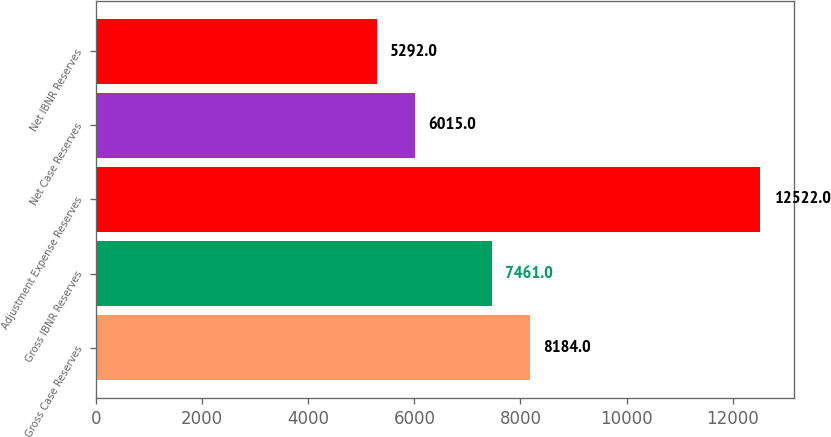Convert chart to OTSL. <chart><loc_0><loc_0><loc_500><loc_500><bar_chart><fcel>Gross Case Reserves<fcel>Gross IBNR Reserves<fcel>Adjustment Expense Reserves<fcel>Net Case Reserves<fcel>Net IBNR Reserves<nl><fcel>8184<fcel>7461<fcel>12522<fcel>6015<fcel>5292<nl></chart> 